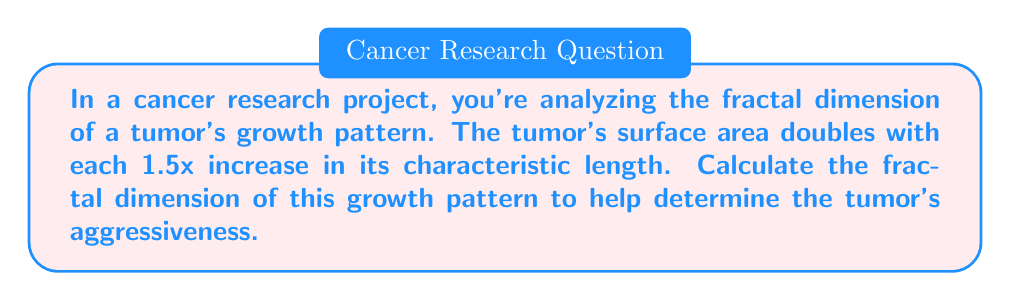Solve this math problem. To solve this problem, we'll use the concept of fractal dimension and its relation to scaling.

Step 1: Recall the formula for fractal dimension (D):
$$ D = \frac{\log(N)}{\log(r)} $$
Where N is the number of self-similar pieces and r is the scaling factor.

Step 2: Identify the given information:
- Surface area doubles: N = 2
- Characteristic length increases by 1.5x: r = 1.5

Step 3: Plug these values into the fractal dimension formula:
$$ D = \frac{\log(2)}{\log(1.5)} $$

Step 4: Calculate the fractal dimension:
$$ D = \frac{\log(2)}{\log(1.5)} \approx 1.7095 $$

This fractal dimension (approximately 1.7095) lies between 1 and 2, indicating that the tumor's growth pattern is more complex than a smooth surface (D=2) but less space-filling than a volume (D=3). This suggests an irregular, potentially aggressive growth pattern.
Answer: $D \approx 1.7095$ 